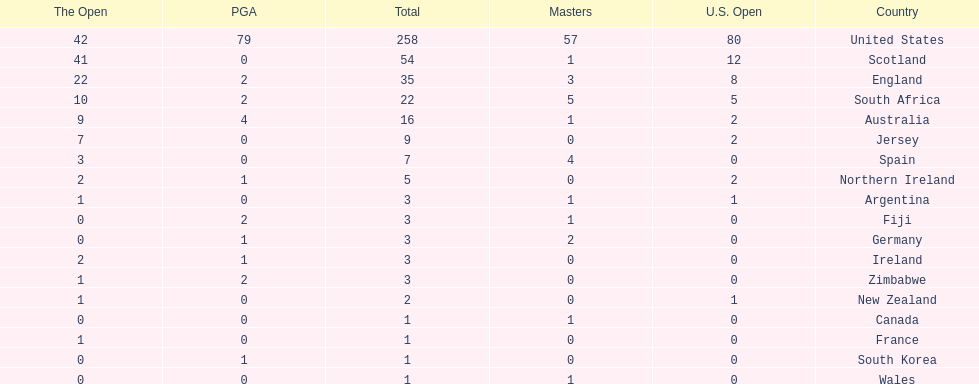Which country has the most pga championships. United States. 